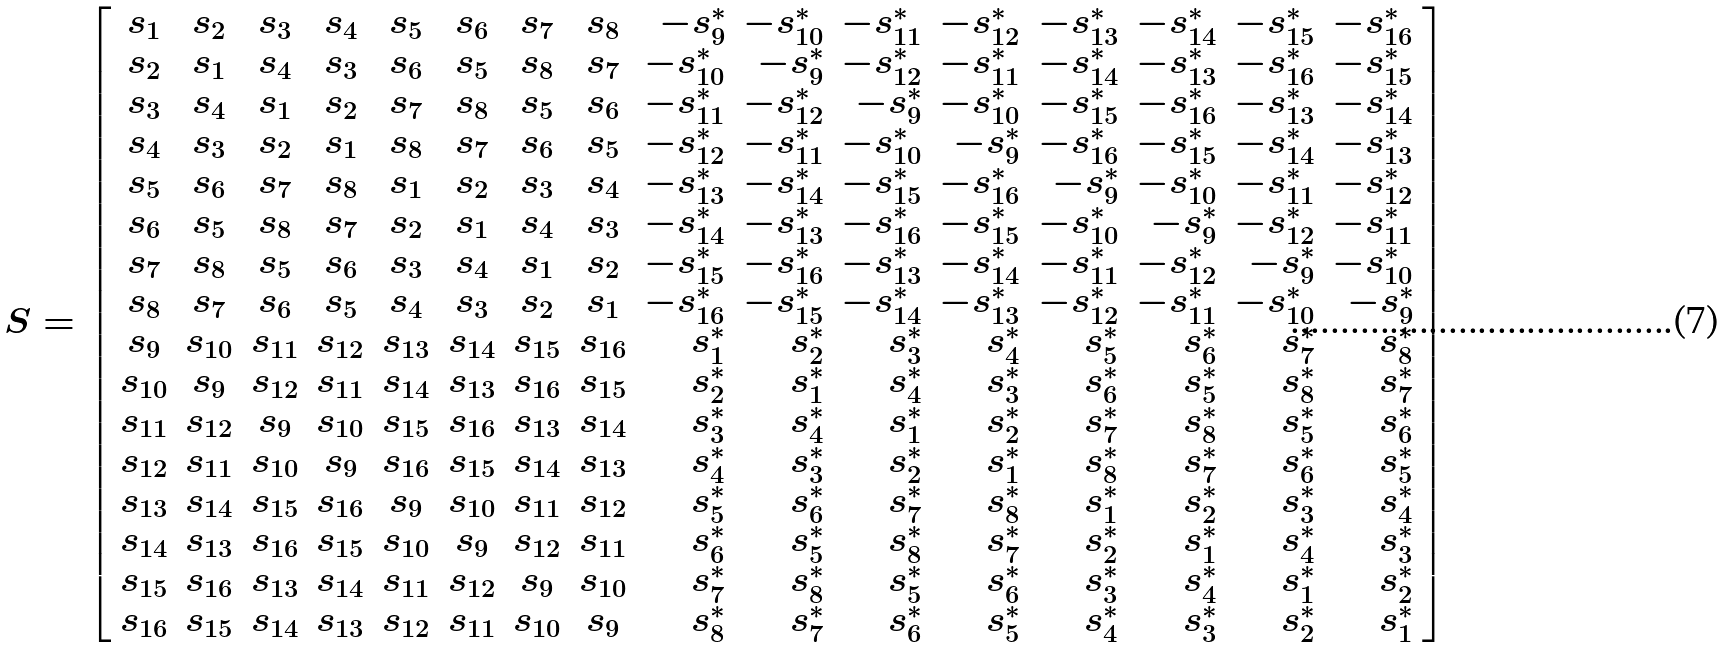<formula> <loc_0><loc_0><loc_500><loc_500>S = \left [ \begin{array} { c c c c c c c c r r r r r r r r } s _ { 1 } & s _ { 2 } & s _ { 3 } & s _ { 4 } & s _ { 5 } & s _ { 6 } & s _ { 7 } & s _ { 8 } & - s _ { 9 } ^ { * } & - s _ { 1 0 } ^ { * } & - s _ { 1 1 } ^ { * } & - s _ { 1 2 } ^ { * } & - s _ { 1 3 } ^ { * } & - s _ { 1 4 } ^ { * } & - s _ { 1 5 } ^ { * } & - s _ { 1 6 } ^ { * } \\ s _ { 2 } & s _ { 1 } & s _ { 4 } & s _ { 3 } & s _ { 6 } & s _ { 5 } & s _ { 8 } & s _ { 7 } & - s _ { 1 0 } ^ { * } & - s _ { 9 } ^ { * } & - s _ { 1 2 } ^ { * } & - s _ { 1 1 } ^ { * } & - s _ { 1 4 } ^ { * } & - s _ { 1 3 } ^ { * } & - s _ { 1 6 } ^ { * } & - s _ { 1 5 } ^ { * } \\ s _ { 3 } & s _ { 4 } & s _ { 1 } & s _ { 2 } & s _ { 7 } & s _ { 8 } & s _ { 5 } & s _ { 6 } & - s _ { 1 1 } ^ { * } & - s _ { 1 2 } ^ { * } & - s _ { 9 } ^ { * } & - s _ { 1 0 } ^ { * } & - s _ { 1 5 } ^ { * } & - s _ { 1 6 } ^ { * } & - s _ { 1 3 } ^ { * } & - s _ { 1 4 } ^ { * } \\ s _ { 4 } & s _ { 3 } & s _ { 2 } & s _ { 1 } & s _ { 8 } & s _ { 7 } & s _ { 6 } & s _ { 5 } & - s _ { 1 2 } ^ { * } & - s _ { 1 1 } ^ { * } & - s _ { 1 0 } ^ { * } & - s _ { 9 } ^ { * } & - s _ { 1 6 } ^ { * } & - s _ { 1 5 } ^ { * } & - s _ { 1 4 } ^ { * } & - s _ { 1 3 } ^ { * } \\ s _ { 5 } & s _ { 6 } & s _ { 7 } & s _ { 8 } & s _ { 1 } & s _ { 2 } & s _ { 3 } & s _ { 4 } & - s _ { 1 3 } ^ { * } & - s _ { 1 4 } ^ { * } & - s _ { 1 5 } ^ { * } & - s _ { 1 6 } ^ { * } & - s _ { 9 } ^ { * } & - s _ { 1 0 } ^ { * } & - s _ { 1 1 } ^ { * } & - s _ { 1 2 } ^ { * } \\ s _ { 6 } & s _ { 5 } & s _ { 8 } & s _ { 7 } & s _ { 2 } & s _ { 1 } & s _ { 4 } & s _ { 3 } & - s _ { 1 4 } ^ { * } & - s _ { 1 3 } ^ { * } & - s _ { 1 6 } ^ { * } & - s _ { 1 5 } ^ { * } & - s _ { 1 0 } ^ { * } & - s _ { 9 } ^ { * } & - s _ { 1 2 } ^ { * } & - s _ { 1 1 } ^ { * } \\ s _ { 7 } & s _ { 8 } & s _ { 5 } & s _ { 6 } & s _ { 3 } & s _ { 4 } & s _ { 1 } & s _ { 2 } & - s _ { 1 5 } ^ { * } & - s _ { 1 6 } ^ { * } & - s _ { 1 3 } ^ { * } & - s _ { 1 4 } ^ { * } & - s _ { 1 1 } ^ { * } & - s _ { 1 2 } ^ { * } & - s _ { 9 } ^ { * } & - s _ { 1 0 } ^ { * } \\ s _ { 8 } & s _ { 7 } & s _ { 6 } & s _ { 5 } & s _ { 4 } & s _ { 3 } & s _ { 2 } & s _ { 1 } & - s _ { 1 6 } ^ { * } & - s _ { 1 5 } ^ { * } & - s _ { 1 4 } ^ { * } & - s _ { 1 3 } ^ { * } & - s _ { 1 2 } ^ { * } & - s _ { 1 1 } ^ { * } & - s _ { 1 0 } ^ { * } & - s _ { 9 } ^ { * } \\ s _ { 9 } & s _ { 1 0 } & s _ { 1 1 } & s _ { 1 2 } & s _ { 1 3 } & s _ { 1 4 } & s _ { 1 5 } & s _ { 1 6 } & s _ { 1 } ^ { * } & s _ { 2 } ^ { * } & s _ { 3 } ^ { * } & s _ { 4 } ^ { * } & s _ { 5 } ^ { * } & s _ { 6 } ^ { * } & s _ { 7 } ^ { * } & s _ { 8 } ^ { * } \\ s _ { 1 0 } & s _ { 9 } & s _ { 1 2 } & s _ { 1 1 } & s _ { 1 4 } & s _ { 1 3 } & s _ { 1 6 } & s _ { 1 5 } & s _ { 2 } ^ { * } & s _ { 1 } ^ { * } & s _ { 4 } ^ { * } & s _ { 3 } ^ { * } & s _ { 6 } ^ { * } & s _ { 5 } ^ { * } & s _ { 8 } ^ { * } & s _ { 7 } ^ { * } \\ s _ { 1 1 } & s _ { 1 2 } & s _ { 9 } & s _ { 1 0 } & s _ { 1 5 } & s _ { 1 6 } & s _ { 1 3 } & s _ { 1 4 } & s _ { 3 } ^ { * } & s _ { 4 } ^ { * } & s _ { 1 } ^ { * } & s _ { 2 } ^ { * } & s _ { 7 } ^ { * } & s _ { 8 } ^ { * } & s _ { 5 } ^ { * } & s _ { 6 } ^ { * } \\ s _ { 1 2 } & s _ { 1 1 } & s _ { 1 0 } & s _ { 9 } & s _ { 1 6 } & s _ { 1 5 } & s _ { 1 4 } & s _ { 1 3 } & s _ { 4 } ^ { * } & s _ { 3 } ^ { * } & s _ { 2 } ^ { * } & s _ { 1 } ^ { * } & s _ { 8 } ^ { * } & s _ { 7 } ^ { * } & s _ { 6 } ^ { * } & s _ { 5 } ^ { * } \\ s _ { 1 3 } & s _ { 1 4 } & s _ { 1 5 } & s _ { 1 6 } & s _ { 9 } & s _ { 1 0 } & s _ { 1 1 } & s _ { 1 2 } & s _ { 5 } ^ { * } & s _ { 6 } ^ { * } & s _ { 7 } ^ { * } & s _ { 8 } ^ { * } & s _ { 1 } ^ { * } & s _ { 2 } ^ { * } & s _ { 3 } ^ { * } & s _ { 4 } ^ { * } \\ s _ { 1 4 } & s _ { 1 3 } & s _ { 1 6 } & s _ { 1 5 } & s _ { 1 0 } & s _ { 9 } & s _ { 1 2 } & s _ { 1 1 } & s _ { 6 } ^ { * } & s _ { 5 } ^ { * } & s _ { 8 } ^ { * } & s _ { 7 } ^ { * } & s _ { 2 } ^ { * } & s _ { 1 } ^ { * } & s _ { 4 } ^ { * } & s _ { 3 } ^ { * } \\ s _ { 1 5 } & s _ { 1 6 } & s _ { 1 3 } & s _ { 1 4 } & s _ { 1 1 } & s _ { 1 2 } & s _ { 9 } & s _ { 1 0 } & s _ { 7 } ^ { * } & s _ { 8 } ^ { * } & s _ { 5 } ^ { * } & s _ { 6 } ^ { * } & s _ { 3 } ^ { * } & s _ { 4 } ^ { * } & s _ { 1 } ^ { * } & s _ { 2 } ^ { * } \\ s _ { 1 6 } & s _ { 1 5 } & s _ { 1 4 } & s _ { 1 3 } & s _ { 1 2 } & s _ { 1 1 } & s _ { 1 0 } & s _ { 9 } & s _ { 8 } ^ { * } & s _ { 7 } ^ { * } & s _ { 6 } ^ { * } & s _ { 5 } ^ { * } & s _ { 4 } ^ { * } & s _ { 3 } ^ { * } & s _ { 2 } ^ { * } & s _ { 1 } ^ { * } \end{array} \right ]</formula> 